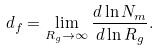Convert formula to latex. <formula><loc_0><loc_0><loc_500><loc_500>d _ { f } = \lim _ { R _ { g } \rightarrow \infty } \frac { d \ln N _ { m } } { d \ln R _ { g } } .</formula> 